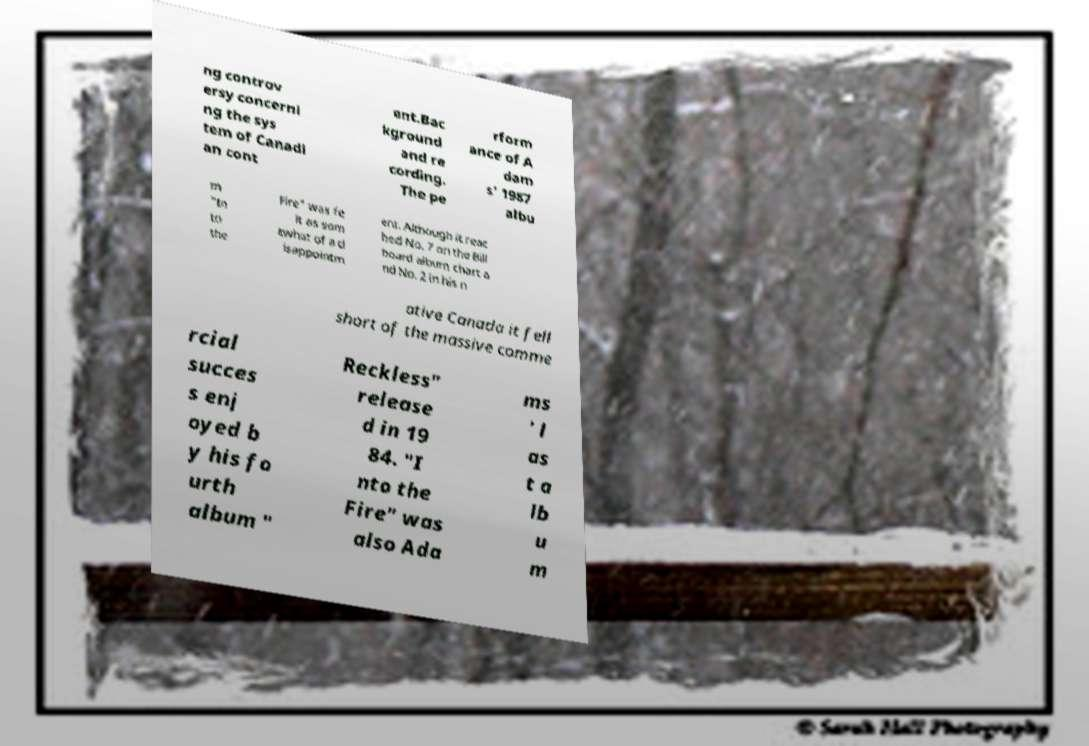Can you read and provide the text displayed in the image?This photo seems to have some interesting text. Can you extract and type it out for me? ng controv ersy concerni ng the sys tem of Canadi an cont ent.Bac kground and re cording. The pe rform ance of A dam s' 1987 albu m "In to the Fire" was fe lt as som ewhat of a d isappointm ent. Although it reac hed No. 7 on the Bill board album chart a nd No. 2 in his n ative Canada it fell short of the massive comme rcial succes s enj oyed b y his fo urth album " Reckless" release d in 19 84. "I nto the Fire" was also Ada ms ' l as t a lb u m 